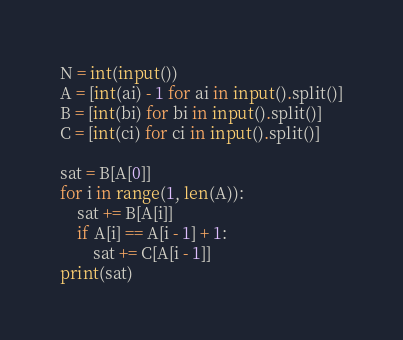<code> <loc_0><loc_0><loc_500><loc_500><_Python_>N = int(input())
A = [int(ai) - 1 for ai in input().split()]
B = [int(bi) for bi in input().split()]
C = [int(ci) for ci in input().split()]

sat = B[A[0]]
for i in range(1, len(A)):
    sat += B[A[i]]
    if A[i] == A[i - 1] + 1:
        sat += C[A[i - 1]]
print(sat)
</code> 